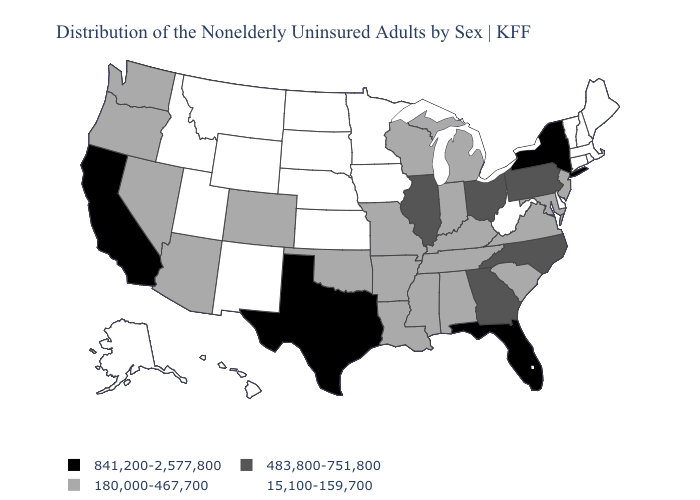What is the value of Minnesota?
Concise answer only. 15,100-159,700. Name the states that have a value in the range 483,800-751,800?
Short answer required. Georgia, Illinois, North Carolina, Ohio, Pennsylvania. Does the first symbol in the legend represent the smallest category?
Be succinct. No. Is the legend a continuous bar?
Give a very brief answer. No. Does Indiana have the highest value in the MidWest?
Answer briefly. No. Does Rhode Island have a lower value than Georgia?
Keep it brief. Yes. Name the states that have a value in the range 841,200-2,577,800?
Answer briefly. California, Florida, New York, Texas. Which states hav the highest value in the West?
Write a very short answer. California. What is the value of Mississippi?
Answer briefly. 180,000-467,700. What is the highest value in the South ?
Give a very brief answer. 841,200-2,577,800. Does the map have missing data?
Write a very short answer. No. What is the lowest value in the Northeast?
Give a very brief answer. 15,100-159,700. Does the first symbol in the legend represent the smallest category?
Quick response, please. No. Name the states that have a value in the range 841,200-2,577,800?
Concise answer only. California, Florida, New York, Texas. Among the states that border Georgia , does Tennessee have the lowest value?
Write a very short answer. Yes. 